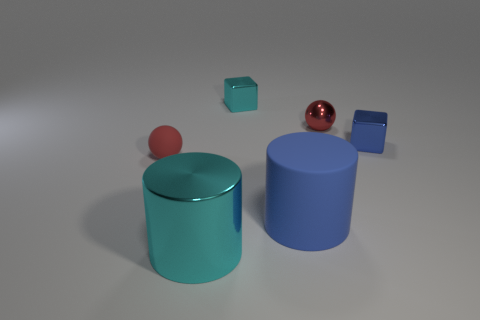What materials do the objects in the image appear to be made of? The objects in the image seem to have different materials. The two cylinders and the blocks appear to have a matte finish suggesting a ceramic or plastic composition, while the sphere has a reflective surface which could either be a polished metal or a glossy plastic material. 